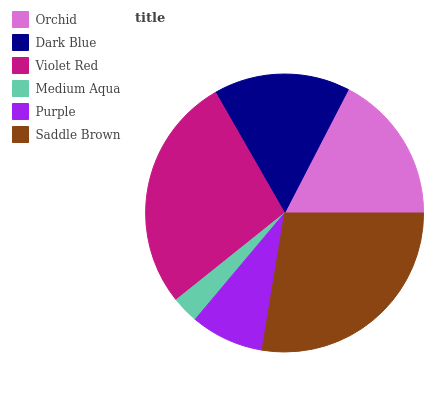Is Medium Aqua the minimum?
Answer yes or no. Yes. Is Saddle Brown the maximum?
Answer yes or no. Yes. Is Dark Blue the minimum?
Answer yes or no. No. Is Dark Blue the maximum?
Answer yes or no. No. Is Orchid greater than Dark Blue?
Answer yes or no. Yes. Is Dark Blue less than Orchid?
Answer yes or no. Yes. Is Dark Blue greater than Orchid?
Answer yes or no. No. Is Orchid less than Dark Blue?
Answer yes or no. No. Is Orchid the high median?
Answer yes or no. Yes. Is Dark Blue the low median?
Answer yes or no. Yes. Is Purple the high median?
Answer yes or no. No. Is Violet Red the low median?
Answer yes or no. No. 